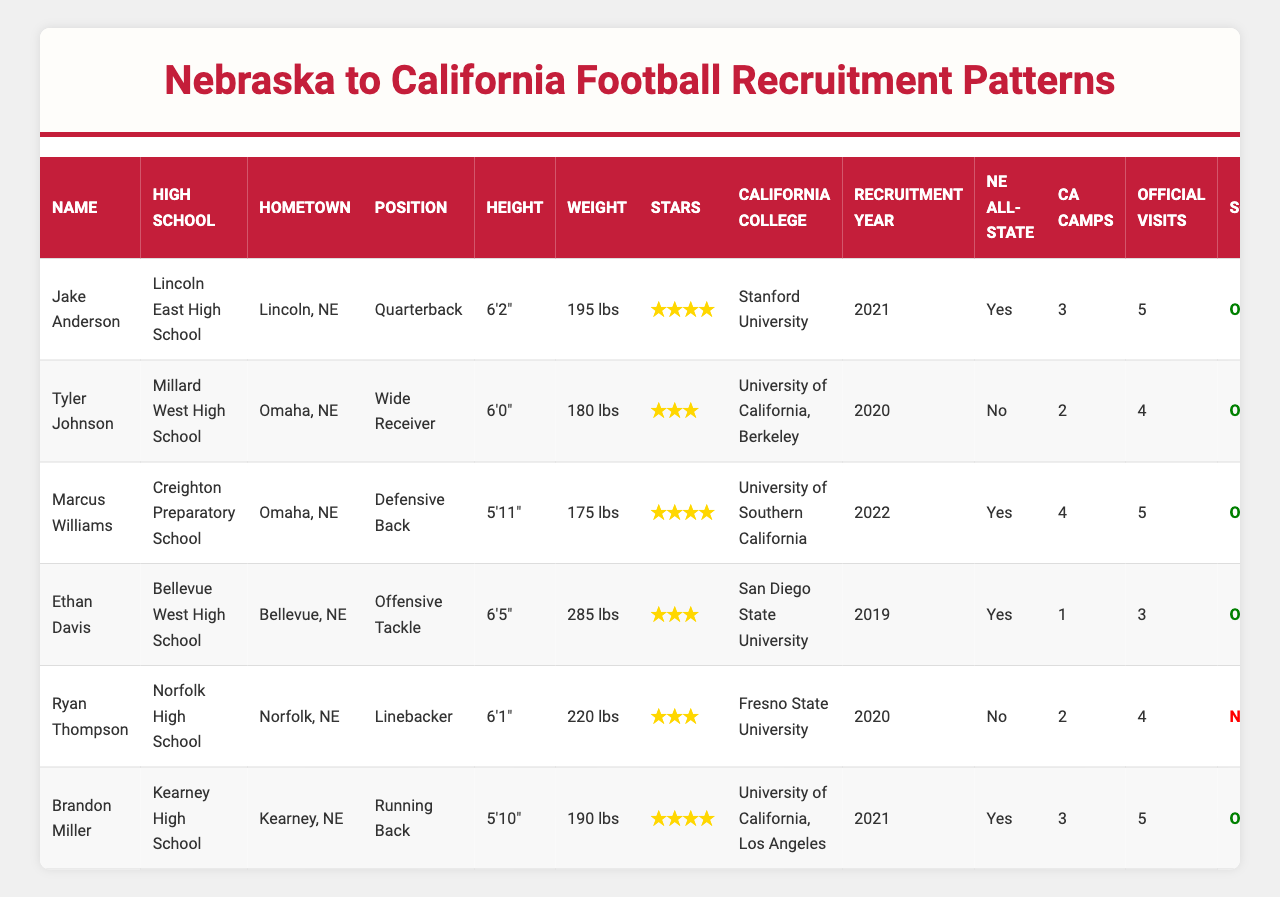What is the name of the player from Lincoln East High School? The player's name can be found in the "Name" column, and the corresponding row for Lincoln East High School indicates that the name is Jake Anderson.
Answer: Jake Anderson Which player has the highest weight? The weights of the players are listed in the table, and by comparing them, Ethan Davis at 285 lbs is the heaviest.
Answer: Ethan Davis How many players are all-state from Nebraska? The table indicates which players are from Nebraska's all-state team with a "Yes" or "No." Counting the "Yes" responses gives us a total of four all-state players.
Answer: 4 What position does Marcus Williams play? The position for each player is listed in the "Position" column. For Marcus Williams, it is listed as Defensive Back.
Answer: Defensive Back How many total scholarship offers were made to the players? By checking the "Scholarship" column for each player, we can see that 5 out of the 7 players received offers, as indicated by the "Offered" status.
Answer: 5 Which California college did the most heavily recruited player (4 stars) attend? Looking at the "Stars" column, two players have 4 stars. Among these, Marcus Williams attended the University of Southern California.
Answer: University of Southern California Is there a player who did not receive a scholarship offer and attended California camps? Reviewing the "Scholarship" column reveals one player, Ryan Thompson, who did not receive a scholarship (Not Offered) but attended California camps (2 attended).
Answer: Yes What is the average number of California camps attended by players who received scholarship offers? For the players that received offers, we add up the camp attendance: 3 (Jake Anderson) + 2 (Tyler Johnson) + 4 (Marcus Williams) + 3 (Brandon Miller) = 12. There are 4 players who received offers, so the average is 12/4 = 3.
Answer: 3 How many official visits did the Nebraska all-state players make on average? Counting the official visits for the all-state players: Jake Anderson (5 visits) + Marcus Williams (5 visits) + Ethan Davis (3 visits) + Brandon Miller (5 visits) = 18 visits total. There are 4 all-state players, so the average is 18/4 = 4.5.
Answer: 4.5 Which player from Kearney High School has the highest star rating, and what is that rating? From the table, Brandon Miller from Kearney High School has a star rating of 4, which is the highest among the listed players.
Answer: 4 stars 